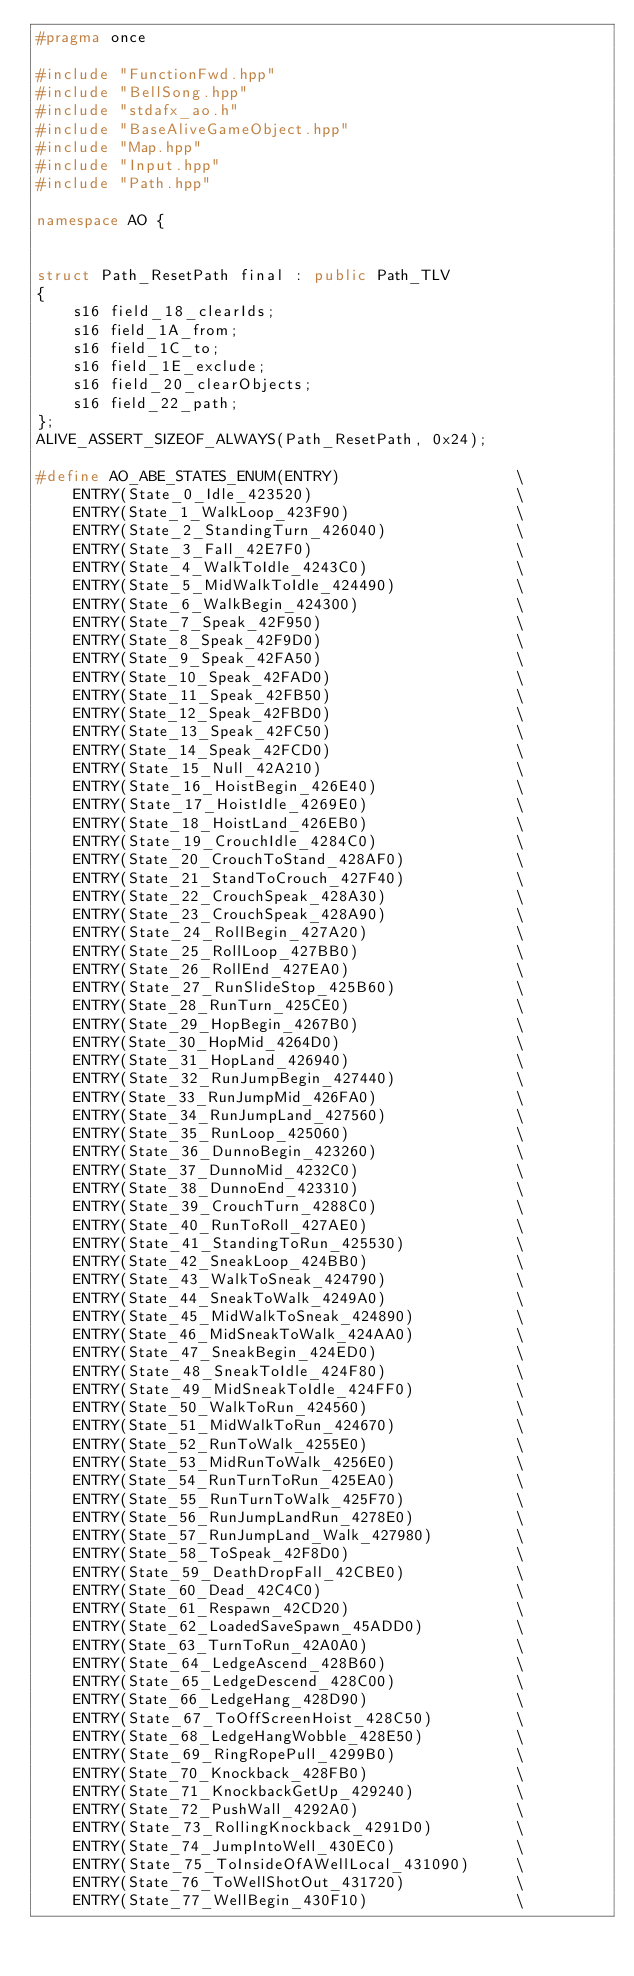<code> <loc_0><loc_0><loc_500><loc_500><_C++_>#pragma once

#include "FunctionFwd.hpp"
#include "BellSong.hpp"
#include "stdafx_ao.h"
#include "BaseAliveGameObject.hpp"
#include "Map.hpp"
#include "Input.hpp"
#include "Path.hpp"

namespace AO {

    
struct Path_ResetPath final : public Path_TLV
{
    s16 field_18_clearIds;
    s16 field_1A_from;
    s16 field_1C_to;
    s16 field_1E_exclude;
    s16 field_20_clearObjects;
    s16 field_22_path;
};
ALIVE_ASSERT_SIZEOF_ALWAYS(Path_ResetPath, 0x24);

#define AO_ABE_STATES_ENUM(ENTRY)                   \
    ENTRY(State_0_Idle_423520)                      \
    ENTRY(State_1_WalkLoop_423F90)                  \
    ENTRY(State_2_StandingTurn_426040)              \
    ENTRY(State_3_Fall_42E7F0)                      \
    ENTRY(State_4_WalkToIdle_4243C0)                \
    ENTRY(State_5_MidWalkToIdle_424490)             \
    ENTRY(State_6_WalkBegin_424300)                 \
    ENTRY(State_7_Speak_42F950)                     \
    ENTRY(State_8_Speak_42F9D0)                     \
    ENTRY(State_9_Speak_42FA50)                     \
    ENTRY(State_10_Speak_42FAD0)                    \
    ENTRY(State_11_Speak_42FB50)                    \
    ENTRY(State_12_Speak_42FBD0)                    \
    ENTRY(State_13_Speak_42FC50)                    \
    ENTRY(State_14_Speak_42FCD0)                    \
    ENTRY(State_15_Null_42A210)                     \
    ENTRY(State_16_HoistBegin_426E40)               \
    ENTRY(State_17_HoistIdle_4269E0)                \
    ENTRY(State_18_HoistLand_426EB0)                \
    ENTRY(State_19_CrouchIdle_4284C0)               \
    ENTRY(State_20_CrouchToStand_428AF0)            \
    ENTRY(State_21_StandToCrouch_427F40)            \
    ENTRY(State_22_CrouchSpeak_428A30)              \
    ENTRY(State_23_CrouchSpeak_428A90)              \
    ENTRY(State_24_RollBegin_427A20)                \
    ENTRY(State_25_RollLoop_427BB0)                 \
    ENTRY(State_26_RollEnd_427EA0)                  \
    ENTRY(State_27_RunSlideStop_425B60)             \
    ENTRY(State_28_RunTurn_425CE0)                  \
    ENTRY(State_29_HopBegin_4267B0)                 \
    ENTRY(State_30_HopMid_4264D0)                   \
    ENTRY(State_31_HopLand_426940)                  \
    ENTRY(State_32_RunJumpBegin_427440)             \
    ENTRY(State_33_RunJumpMid_426FA0)               \
    ENTRY(State_34_RunJumpLand_427560)              \
    ENTRY(State_35_RunLoop_425060)                  \
    ENTRY(State_36_DunnoBegin_423260)               \
    ENTRY(State_37_DunnoMid_4232C0)                 \
    ENTRY(State_38_DunnoEnd_423310)                 \
    ENTRY(State_39_CrouchTurn_4288C0)               \
    ENTRY(State_40_RunToRoll_427AE0)                \
    ENTRY(State_41_StandingToRun_425530)            \
    ENTRY(State_42_SneakLoop_424BB0)                \
    ENTRY(State_43_WalkToSneak_424790)              \
    ENTRY(State_44_SneakToWalk_4249A0)              \
    ENTRY(State_45_MidWalkToSneak_424890)           \
    ENTRY(State_46_MidSneakToWalk_424AA0)           \
    ENTRY(State_47_SneakBegin_424ED0)               \
    ENTRY(State_48_SneakToIdle_424F80)              \
    ENTRY(State_49_MidSneakToIdle_424FF0)           \
    ENTRY(State_50_WalkToRun_424560)                \
    ENTRY(State_51_MidWalkToRun_424670)             \
    ENTRY(State_52_RunToWalk_4255E0)                \
    ENTRY(State_53_MidRunToWalk_4256E0)             \
    ENTRY(State_54_RunTurnToRun_425EA0)             \
    ENTRY(State_55_RunTurnToWalk_425F70)            \
    ENTRY(State_56_RunJumpLandRun_4278E0)           \
    ENTRY(State_57_RunJumpLand_Walk_427980)         \
    ENTRY(State_58_ToSpeak_42F8D0)                  \
    ENTRY(State_59_DeathDropFall_42CBE0)            \
    ENTRY(State_60_Dead_42C4C0)                     \
    ENTRY(State_61_Respawn_42CD20)                  \
    ENTRY(State_62_LoadedSaveSpawn_45ADD0)          \
    ENTRY(State_63_TurnToRun_42A0A0)                \
    ENTRY(State_64_LedgeAscend_428B60)              \
    ENTRY(State_65_LedgeDescend_428C00)             \
    ENTRY(State_66_LedgeHang_428D90)                \
    ENTRY(State_67_ToOffScreenHoist_428C50)         \
    ENTRY(State_68_LedgeHangWobble_428E50)          \
    ENTRY(State_69_RingRopePull_4299B0)             \
    ENTRY(State_70_Knockback_428FB0)                \
    ENTRY(State_71_KnockbackGetUp_429240)           \
    ENTRY(State_72_PushWall_4292A0)                 \
    ENTRY(State_73_RollingKnockback_4291D0)         \
    ENTRY(State_74_JumpIntoWell_430EC0)             \
    ENTRY(State_75_ToInsideOfAWellLocal_431090)     \
    ENTRY(State_76_ToWellShotOut_431720)            \
    ENTRY(State_77_WellBegin_430F10)                \</code> 